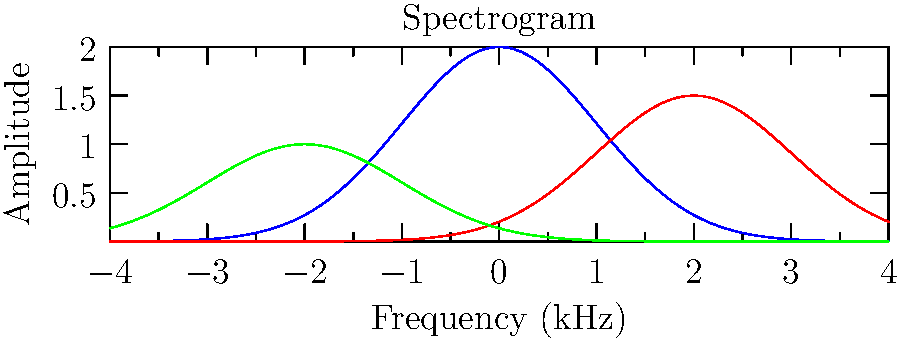Analyze the spectrogram of three different vocal techniques: belting, head voice, and falsetto. Which technique typically exhibits the highest amplitude in the higher frequency range, and how does this relate to its perceived vocal quality? To analyze the spectrogram and answer this question, let's follow these steps:

1. Identify the curves:
   - Blue curve: Belting
   - Red curve: Head voice
   - Green curve: Falsetto

2. Compare amplitudes at higher frequencies:
   - Belting (blue) has the highest amplitude across most of the frequency range.
   - Head voice (red) has a moderate amplitude, peaking later in the frequency range.
   - Falsetto (green) has the lowest overall amplitude.

3. Analyze the implications:
   - Belting shows the highest amplitude in higher frequencies, indicating a rich harmonic content.
   - This richness in harmonics contributes to the powerful, bright quality associated with belting.

4. Relate to perceived vocal quality:
   - Belting is often described as a strong, resonant sound with a "forward" placement.
   - The high amplitude in upper frequencies creates a cutting, projecting quality.
   - This technique is often used in musical theater and pop music for dramatic effect.

5. Consider the other techniques:
   - Head voice has a more balanced spectrum, reflecting its mix of chest and head resonance.
   - Falsetto shows less energy in higher frequencies, corresponding to its lighter, airier quality.

Therefore, belting exhibits the highest amplitude in the higher frequency range, which contributes to its perceived powerful and bright vocal quality.
Answer: Belting; rich harmonic content creates a powerful, bright sound. 